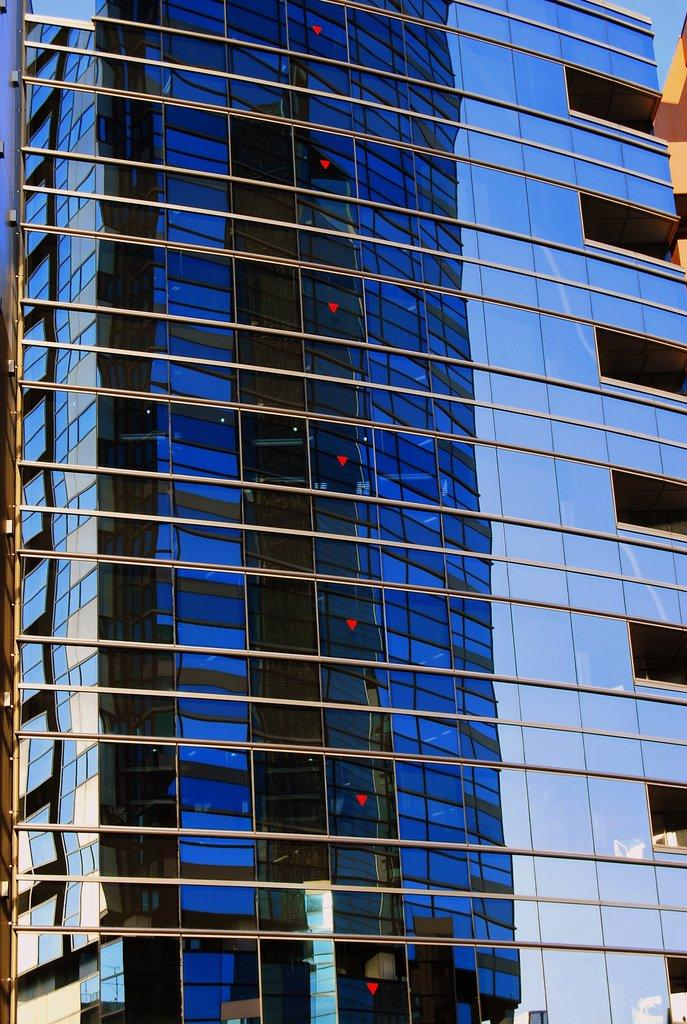What type of structure is present in the image? There is a building in the image. What part of the natural environment is visible in the image? The sky is visible in the image. Is there a tent visible in the image? No, there is no tent present in the image. Is the image set during the night? The provided facts do not mention the time of day, so we cannot determine if it is set during the night. 